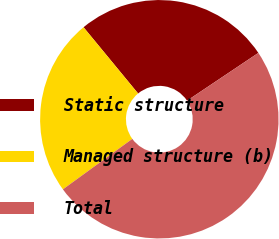Convert chart to OTSL. <chart><loc_0><loc_0><loc_500><loc_500><pie_chart><fcel>Static structure<fcel>Managed structure (b)<fcel>Total<nl><fcel>26.57%<fcel>24.04%<fcel>49.39%<nl></chart> 